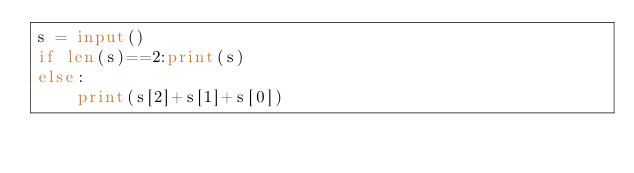<code> <loc_0><loc_0><loc_500><loc_500><_Python_>s = input()
if len(s)==2:print(s)
else:
    print(s[2]+s[1]+s[0])</code> 